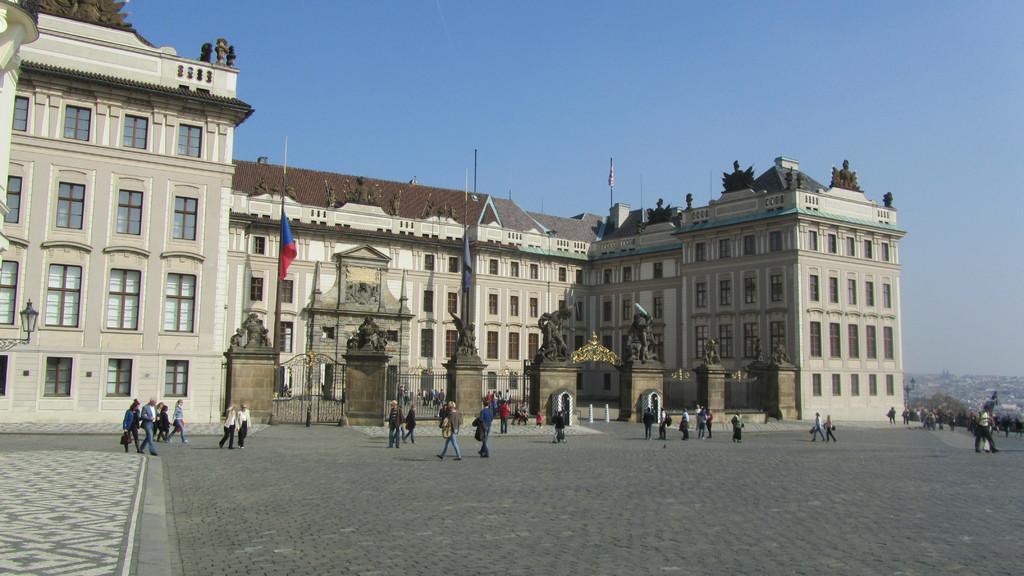Please provide a concise description of this image. In this image there is a building and we can see sculptures on the walls. We can see gates. At the bottom there are people walking and there are flags. In the background there is sky. 